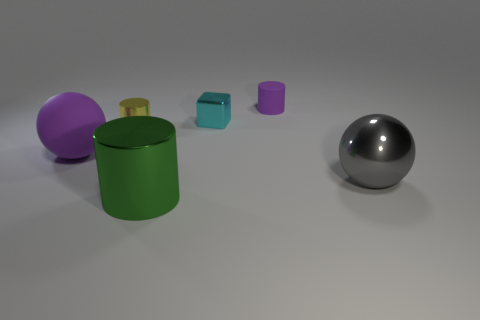What is the approximate ratio of the diameter of the green cylinder to the diameter of the purple sphere? Based on the image, the diameter of the green cylinder appears to be roughly the same as the diameter of the purple sphere. Therefore, the ratio of their diameters would be approximately 1:1. 